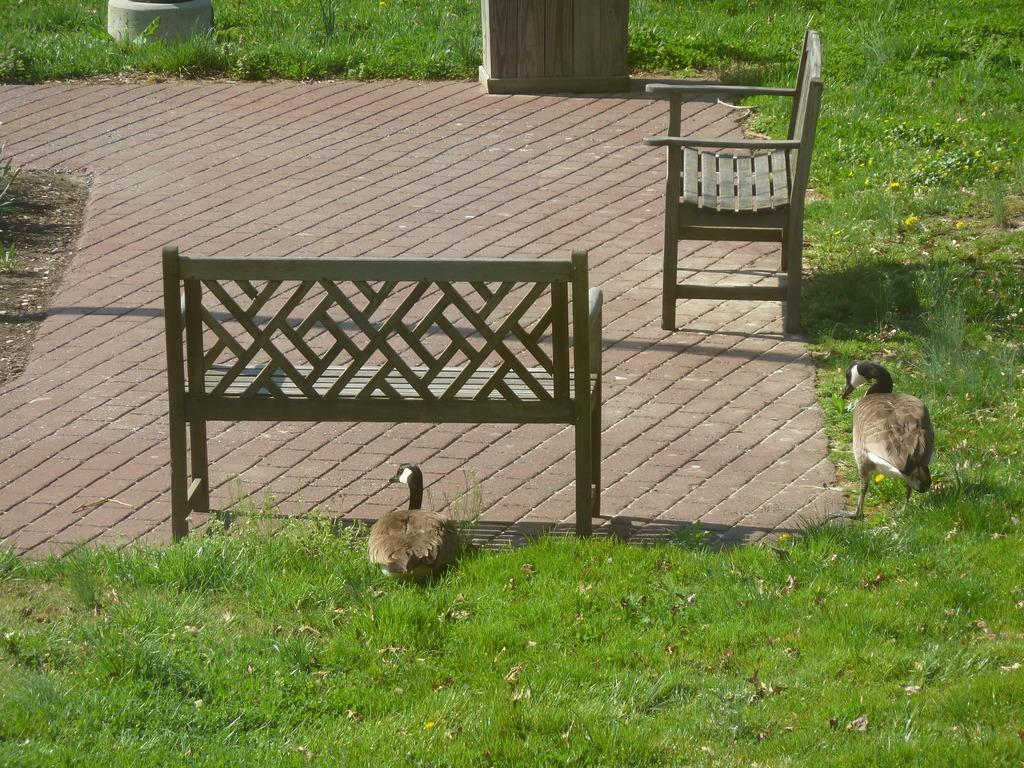Where was the image taken? The image was taken outdoors. What type of furniture can be seen on the floor in the image? There are two benches on the floor. What type of animals are visible in the image? There are two birds visible. What type of vegetation is present in the image? There is grass in the image. Can you tell me what the birds and the people on the benches are arguing about in the image? There are no people present in the image, only birds. Additionally, there is no indication of an argument taking place. 